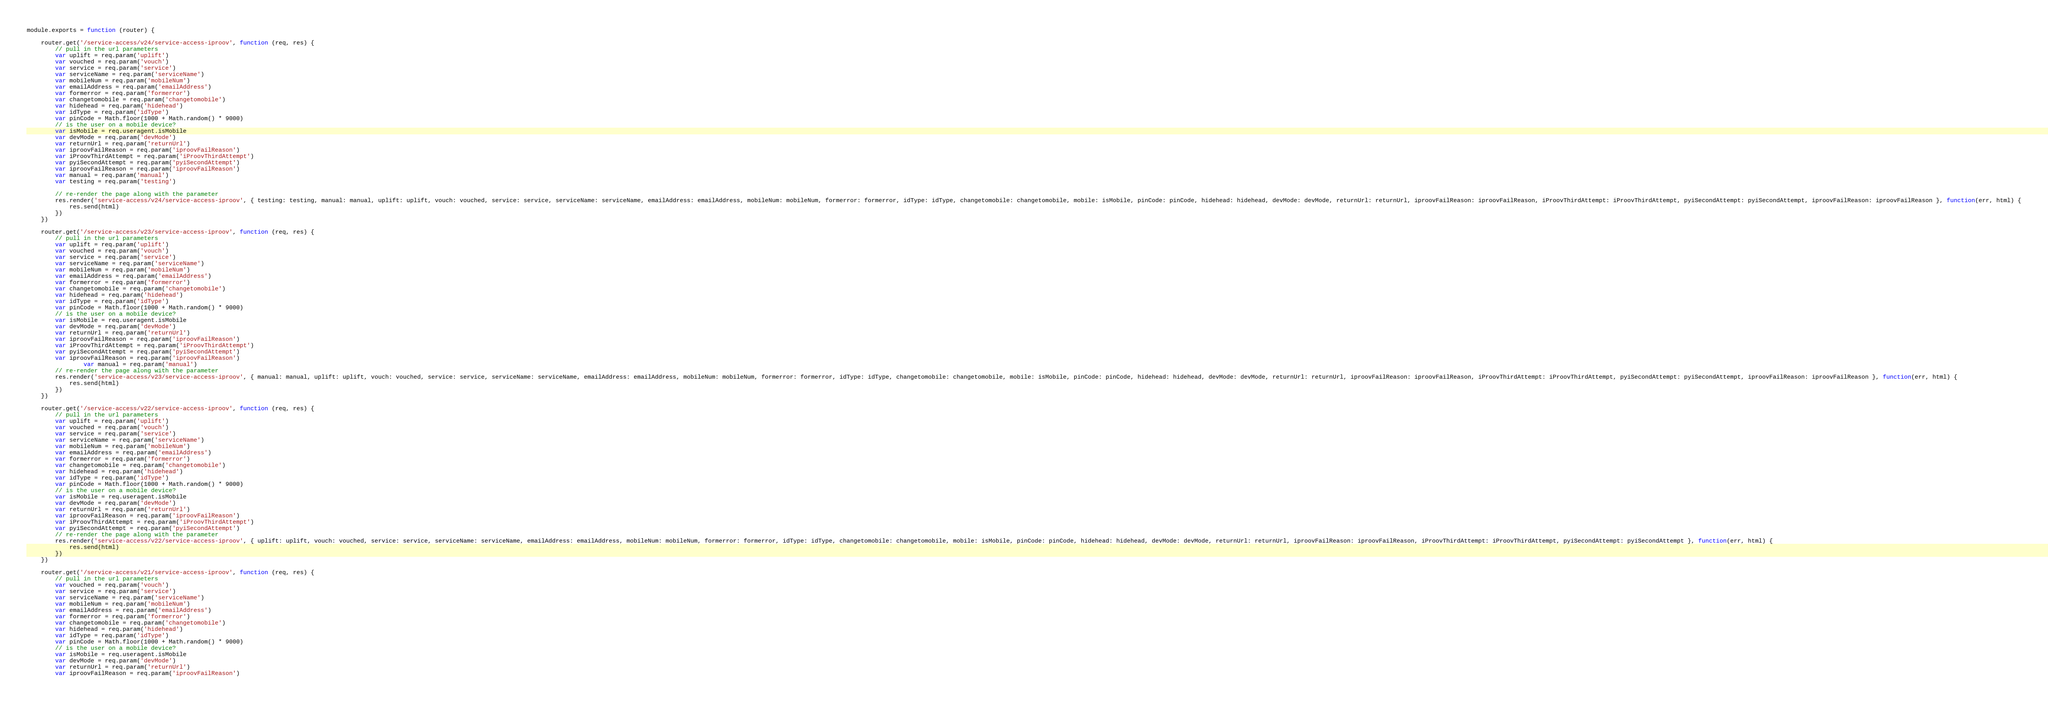<code> <loc_0><loc_0><loc_500><loc_500><_JavaScript_>module.exports = function (router) {

    router.get('/service-access/v24/service-access-iproov', function (req, res) {
        // pull in the url parameters
        var uplift = req.param('uplift')
        var vouched = req.param('vouch')
        var service = req.param('service')
        var serviceName = req.param('serviceName')
        var mobileNum = req.param('mobileNum')
        var emailAddress = req.param('emailAddress')
        var formerror = req.param('formerror')
        var changetomobile = req.param('changetomobile')
        var hidehead = req.param('hidehead')
        var idType = req.param('idType')
        var pinCode = Math.floor(1000 + Math.random() * 9000)
        // is the user on a mobile device?
        var isMobile = req.useragent.isMobile
        var devMode = req.param('devMode')
        var returnUrl = req.param('returnUrl')
        var iproovFailReason = req.param('iproovFailReason')
        var iProovThirdAttempt = req.param('iProovThirdAttempt')
        var pyiSecondAttempt = req.param('pyiSecondAttempt')
        var iproovFailReason = req.param('iproovFailReason')
        var manual = req.param('manual')
        var testing = req.param('testing')

        // re-render the page along with the parameter
        res.render('service-access/v24/service-access-iproov', { testing: testing, manual: manual, uplift: uplift, vouch: vouched, service: service, serviceName: serviceName, emailAddress: emailAddress, mobileNum: mobileNum, formerror: formerror, idType: idType, changetomobile: changetomobile, mobile: isMobile, pinCode: pinCode, hidehead: hidehead, devMode: devMode, returnUrl: returnUrl, iproovFailReason: iproovFailReason, iProovThirdAttempt: iProovThirdAttempt, pyiSecondAttempt: pyiSecondAttempt, iproovFailReason: iproovFailReason }, function(err, html) {
            res.send(html)
        })
    })

    router.get('/service-access/v23/service-access-iproov', function (req, res) {
        // pull in the url parameters
        var uplift = req.param('uplift')
        var vouched = req.param('vouch')
        var service = req.param('service')
        var serviceName = req.param('serviceName')
        var mobileNum = req.param('mobileNum')
        var emailAddress = req.param('emailAddress')
        var formerror = req.param('formerror')
        var changetomobile = req.param('changetomobile')
        var hidehead = req.param('hidehead')
        var idType = req.param('idType')
        var pinCode = Math.floor(1000 + Math.random() * 9000)
        // is the user on a mobile device?
        var isMobile = req.useragent.isMobile
        var devMode = req.param('devMode')
        var returnUrl = req.param('returnUrl')
        var iproovFailReason = req.param('iproovFailReason')
        var iProovThirdAttempt = req.param('iProovThirdAttempt')
        var pyiSecondAttempt = req.param('pyiSecondAttempt')
        var iproovFailReason = req.param('iproovFailReason')
                var manual = req.param('manual')
        // re-render the page along with the parameter
        res.render('service-access/v23/service-access-iproov', { manual: manual, uplift: uplift, vouch: vouched, service: service, serviceName: serviceName, emailAddress: emailAddress, mobileNum: mobileNum, formerror: formerror, idType: idType, changetomobile: changetomobile, mobile: isMobile, pinCode: pinCode, hidehead: hidehead, devMode: devMode, returnUrl: returnUrl, iproovFailReason: iproovFailReason, iProovThirdAttempt: iProovThirdAttempt, pyiSecondAttempt: pyiSecondAttempt, iproovFailReason: iproovFailReason }, function(err, html) {
            res.send(html)
        })
    })

    router.get('/service-access/v22/service-access-iproov', function (req, res) {
        // pull in the url parameters
        var uplift = req.param('uplift')
        var vouched = req.param('vouch')
        var service = req.param('service')
        var serviceName = req.param('serviceName')
        var mobileNum = req.param('mobileNum')
        var emailAddress = req.param('emailAddress')
        var formerror = req.param('formerror')
        var changetomobile = req.param('changetomobile')
        var hidehead = req.param('hidehead')
        var idType = req.param('idType')
        var pinCode = Math.floor(1000 + Math.random() * 9000)
        // is the user on a mobile device?
        var isMobile = req.useragent.isMobile
        var devMode = req.param('devMode')
        var returnUrl = req.param('returnUrl')
        var iproovFailReason = req.param('iproovFailReason')
        var iProovThirdAttempt = req.param('iProovThirdAttempt')
        var pyiSecondAttempt = req.param('pyiSecondAttempt')
        // re-render the page along with the parameter
        res.render('service-access/v22/service-access-iproov', { uplift: uplift, vouch: vouched, service: service, serviceName: serviceName, emailAddress: emailAddress, mobileNum: mobileNum, formerror: formerror, idType: idType, changetomobile: changetomobile, mobile: isMobile, pinCode: pinCode, hidehead: hidehead, devMode: devMode, returnUrl: returnUrl, iproovFailReason: iproovFailReason, iProovThirdAttempt: iProovThirdAttempt, pyiSecondAttempt: pyiSecondAttempt }, function(err, html) {
            res.send(html)
        })
    })

    router.get('/service-access/v21/service-access-iproov', function (req, res) {
        // pull in the url parameters
        var vouched = req.param('vouch')
        var service = req.param('service')
        var serviceName = req.param('serviceName')
        var mobileNum = req.param('mobileNum')
        var emailAddress = req.param('emailAddress')
        var formerror = req.param('formerror')
        var changetomobile = req.param('changetomobile')
        var hidehead = req.param('hidehead')
        var idType = req.param('idType')
        var pinCode = Math.floor(1000 + Math.random() * 9000)
        // is the user on a mobile device?
        var isMobile = req.useragent.isMobile
        var devMode = req.param('devMode')
        var returnUrl = req.param('returnUrl')
        var iproovFailReason = req.param('iproovFailReason')</code> 